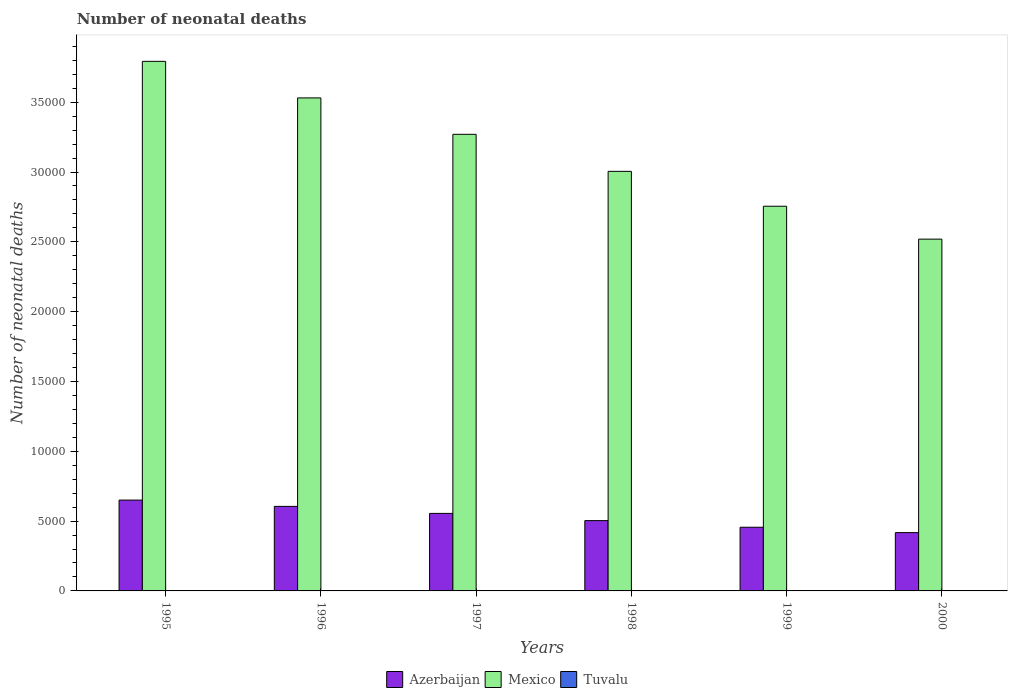Are the number of bars on each tick of the X-axis equal?
Make the answer very short. Yes. In how many cases, is the number of bars for a given year not equal to the number of legend labels?
Provide a short and direct response. 0. What is the number of neonatal deaths in in Mexico in 1997?
Ensure brevity in your answer.  3.27e+04. Across all years, what is the maximum number of neonatal deaths in in Mexico?
Your answer should be compact. 3.79e+04. In which year was the number of neonatal deaths in in Mexico maximum?
Provide a succinct answer. 1995. What is the total number of neonatal deaths in in Mexico in the graph?
Provide a succinct answer. 1.89e+05. What is the difference between the number of neonatal deaths in in Azerbaijan in 1995 and that in 1996?
Your response must be concise. 451. What is the difference between the number of neonatal deaths in in Tuvalu in 1997 and the number of neonatal deaths in in Mexico in 1998?
Make the answer very short. -3.00e+04. What is the average number of neonatal deaths in in Mexico per year?
Ensure brevity in your answer.  3.15e+04. In the year 2000, what is the difference between the number of neonatal deaths in in Tuvalu and number of neonatal deaths in in Azerbaijan?
Provide a short and direct response. -4169. In how many years, is the number of neonatal deaths in in Mexico greater than 2000?
Make the answer very short. 6. What is the ratio of the number of neonatal deaths in in Azerbaijan in 1995 to that in 2000?
Keep it short and to the point. 1.56. Is the number of neonatal deaths in in Azerbaijan in 1995 less than that in 1998?
Ensure brevity in your answer.  No. Is the difference between the number of neonatal deaths in in Tuvalu in 1995 and 1997 greater than the difference between the number of neonatal deaths in in Azerbaijan in 1995 and 1997?
Your response must be concise. No. What is the difference between the highest and the second highest number of neonatal deaths in in Tuvalu?
Make the answer very short. 0. What is the difference between the highest and the lowest number of neonatal deaths in in Mexico?
Make the answer very short. 1.27e+04. In how many years, is the number of neonatal deaths in in Mexico greater than the average number of neonatal deaths in in Mexico taken over all years?
Offer a terse response. 3. What does the 2nd bar from the left in 1999 represents?
Keep it short and to the point. Mexico. What does the 1st bar from the right in 1999 represents?
Your answer should be compact. Tuvalu. How many years are there in the graph?
Make the answer very short. 6. Are the values on the major ticks of Y-axis written in scientific E-notation?
Provide a succinct answer. No. Where does the legend appear in the graph?
Provide a short and direct response. Bottom center. How many legend labels are there?
Give a very brief answer. 3. How are the legend labels stacked?
Provide a succinct answer. Horizontal. What is the title of the graph?
Provide a short and direct response. Number of neonatal deaths. Does "Cabo Verde" appear as one of the legend labels in the graph?
Offer a terse response. No. What is the label or title of the X-axis?
Your answer should be compact. Years. What is the label or title of the Y-axis?
Offer a terse response. Number of neonatal deaths. What is the Number of neonatal deaths in Azerbaijan in 1995?
Your answer should be very brief. 6505. What is the Number of neonatal deaths of Mexico in 1995?
Your answer should be very brief. 3.79e+04. What is the Number of neonatal deaths of Tuvalu in 1995?
Your answer should be very brief. 6. What is the Number of neonatal deaths of Azerbaijan in 1996?
Offer a very short reply. 6054. What is the Number of neonatal deaths of Mexico in 1996?
Your response must be concise. 3.53e+04. What is the Number of neonatal deaths of Tuvalu in 1996?
Your answer should be compact. 6. What is the Number of neonatal deaths of Azerbaijan in 1997?
Ensure brevity in your answer.  5552. What is the Number of neonatal deaths in Mexico in 1997?
Your response must be concise. 3.27e+04. What is the Number of neonatal deaths of Tuvalu in 1997?
Make the answer very short. 7. What is the Number of neonatal deaths in Azerbaijan in 1998?
Offer a terse response. 5035. What is the Number of neonatal deaths of Mexico in 1998?
Your answer should be very brief. 3.00e+04. What is the Number of neonatal deaths of Azerbaijan in 1999?
Your response must be concise. 4560. What is the Number of neonatal deaths of Mexico in 1999?
Make the answer very short. 2.76e+04. What is the Number of neonatal deaths of Azerbaijan in 2000?
Ensure brevity in your answer.  4176. What is the Number of neonatal deaths of Mexico in 2000?
Keep it short and to the point. 2.52e+04. What is the Number of neonatal deaths of Tuvalu in 2000?
Give a very brief answer. 7. Across all years, what is the maximum Number of neonatal deaths in Azerbaijan?
Your answer should be compact. 6505. Across all years, what is the maximum Number of neonatal deaths of Mexico?
Keep it short and to the point. 3.79e+04. Across all years, what is the minimum Number of neonatal deaths of Azerbaijan?
Offer a terse response. 4176. Across all years, what is the minimum Number of neonatal deaths in Mexico?
Your response must be concise. 2.52e+04. What is the total Number of neonatal deaths in Azerbaijan in the graph?
Your answer should be compact. 3.19e+04. What is the total Number of neonatal deaths in Mexico in the graph?
Give a very brief answer. 1.89e+05. What is the total Number of neonatal deaths in Tuvalu in the graph?
Offer a very short reply. 40. What is the difference between the Number of neonatal deaths in Azerbaijan in 1995 and that in 1996?
Make the answer very short. 451. What is the difference between the Number of neonatal deaths in Mexico in 1995 and that in 1996?
Your answer should be compact. 2618. What is the difference between the Number of neonatal deaths of Tuvalu in 1995 and that in 1996?
Offer a terse response. 0. What is the difference between the Number of neonatal deaths of Azerbaijan in 1995 and that in 1997?
Provide a succinct answer. 953. What is the difference between the Number of neonatal deaths in Mexico in 1995 and that in 1997?
Provide a short and direct response. 5225. What is the difference between the Number of neonatal deaths in Tuvalu in 1995 and that in 1997?
Offer a terse response. -1. What is the difference between the Number of neonatal deaths in Azerbaijan in 1995 and that in 1998?
Your answer should be compact. 1470. What is the difference between the Number of neonatal deaths in Mexico in 1995 and that in 1998?
Offer a terse response. 7877. What is the difference between the Number of neonatal deaths of Azerbaijan in 1995 and that in 1999?
Offer a very short reply. 1945. What is the difference between the Number of neonatal deaths of Mexico in 1995 and that in 1999?
Provide a succinct answer. 1.04e+04. What is the difference between the Number of neonatal deaths in Azerbaijan in 1995 and that in 2000?
Offer a very short reply. 2329. What is the difference between the Number of neonatal deaths of Mexico in 1995 and that in 2000?
Your response must be concise. 1.27e+04. What is the difference between the Number of neonatal deaths of Azerbaijan in 1996 and that in 1997?
Provide a short and direct response. 502. What is the difference between the Number of neonatal deaths of Mexico in 1996 and that in 1997?
Your answer should be compact. 2607. What is the difference between the Number of neonatal deaths of Azerbaijan in 1996 and that in 1998?
Make the answer very short. 1019. What is the difference between the Number of neonatal deaths in Mexico in 1996 and that in 1998?
Give a very brief answer. 5259. What is the difference between the Number of neonatal deaths of Azerbaijan in 1996 and that in 1999?
Give a very brief answer. 1494. What is the difference between the Number of neonatal deaths of Mexico in 1996 and that in 1999?
Your response must be concise. 7757. What is the difference between the Number of neonatal deaths in Azerbaijan in 1996 and that in 2000?
Your response must be concise. 1878. What is the difference between the Number of neonatal deaths in Mexico in 1996 and that in 2000?
Keep it short and to the point. 1.01e+04. What is the difference between the Number of neonatal deaths of Tuvalu in 1996 and that in 2000?
Provide a short and direct response. -1. What is the difference between the Number of neonatal deaths of Azerbaijan in 1997 and that in 1998?
Offer a very short reply. 517. What is the difference between the Number of neonatal deaths of Mexico in 1997 and that in 1998?
Provide a short and direct response. 2652. What is the difference between the Number of neonatal deaths in Tuvalu in 1997 and that in 1998?
Your answer should be very brief. 0. What is the difference between the Number of neonatal deaths in Azerbaijan in 1997 and that in 1999?
Provide a short and direct response. 992. What is the difference between the Number of neonatal deaths in Mexico in 1997 and that in 1999?
Your answer should be compact. 5150. What is the difference between the Number of neonatal deaths in Tuvalu in 1997 and that in 1999?
Ensure brevity in your answer.  0. What is the difference between the Number of neonatal deaths of Azerbaijan in 1997 and that in 2000?
Your answer should be very brief. 1376. What is the difference between the Number of neonatal deaths in Mexico in 1997 and that in 2000?
Your response must be concise. 7507. What is the difference between the Number of neonatal deaths in Azerbaijan in 1998 and that in 1999?
Give a very brief answer. 475. What is the difference between the Number of neonatal deaths of Mexico in 1998 and that in 1999?
Offer a very short reply. 2498. What is the difference between the Number of neonatal deaths of Tuvalu in 1998 and that in 1999?
Ensure brevity in your answer.  0. What is the difference between the Number of neonatal deaths of Azerbaijan in 1998 and that in 2000?
Provide a succinct answer. 859. What is the difference between the Number of neonatal deaths in Mexico in 1998 and that in 2000?
Keep it short and to the point. 4855. What is the difference between the Number of neonatal deaths in Tuvalu in 1998 and that in 2000?
Ensure brevity in your answer.  0. What is the difference between the Number of neonatal deaths of Azerbaijan in 1999 and that in 2000?
Your response must be concise. 384. What is the difference between the Number of neonatal deaths of Mexico in 1999 and that in 2000?
Your response must be concise. 2357. What is the difference between the Number of neonatal deaths of Azerbaijan in 1995 and the Number of neonatal deaths of Mexico in 1996?
Your answer should be compact. -2.88e+04. What is the difference between the Number of neonatal deaths of Azerbaijan in 1995 and the Number of neonatal deaths of Tuvalu in 1996?
Your answer should be very brief. 6499. What is the difference between the Number of neonatal deaths of Mexico in 1995 and the Number of neonatal deaths of Tuvalu in 1996?
Your answer should be compact. 3.79e+04. What is the difference between the Number of neonatal deaths in Azerbaijan in 1995 and the Number of neonatal deaths in Mexico in 1997?
Give a very brief answer. -2.62e+04. What is the difference between the Number of neonatal deaths of Azerbaijan in 1995 and the Number of neonatal deaths of Tuvalu in 1997?
Make the answer very short. 6498. What is the difference between the Number of neonatal deaths of Mexico in 1995 and the Number of neonatal deaths of Tuvalu in 1997?
Your answer should be very brief. 3.79e+04. What is the difference between the Number of neonatal deaths of Azerbaijan in 1995 and the Number of neonatal deaths of Mexico in 1998?
Offer a very short reply. -2.35e+04. What is the difference between the Number of neonatal deaths in Azerbaijan in 1995 and the Number of neonatal deaths in Tuvalu in 1998?
Your answer should be very brief. 6498. What is the difference between the Number of neonatal deaths of Mexico in 1995 and the Number of neonatal deaths of Tuvalu in 1998?
Keep it short and to the point. 3.79e+04. What is the difference between the Number of neonatal deaths in Azerbaijan in 1995 and the Number of neonatal deaths in Mexico in 1999?
Provide a succinct answer. -2.10e+04. What is the difference between the Number of neonatal deaths of Azerbaijan in 1995 and the Number of neonatal deaths of Tuvalu in 1999?
Make the answer very short. 6498. What is the difference between the Number of neonatal deaths in Mexico in 1995 and the Number of neonatal deaths in Tuvalu in 1999?
Offer a very short reply. 3.79e+04. What is the difference between the Number of neonatal deaths in Azerbaijan in 1995 and the Number of neonatal deaths in Mexico in 2000?
Offer a terse response. -1.87e+04. What is the difference between the Number of neonatal deaths of Azerbaijan in 1995 and the Number of neonatal deaths of Tuvalu in 2000?
Provide a succinct answer. 6498. What is the difference between the Number of neonatal deaths of Mexico in 1995 and the Number of neonatal deaths of Tuvalu in 2000?
Your answer should be very brief. 3.79e+04. What is the difference between the Number of neonatal deaths of Azerbaijan in 1996 and the Number of neonatal deaths of Mexico in 1997?
Offer a terse response. -2.66e+04. What is the difference between the Number of neonatal deaths in Azerbaijan in 1996 and the Number of neonatal deaths in Tuvalu in 1997?
Provide a short and direct response. 6047. What is the difference between the Number of neonatal deaths of Mexico in 1996 and the Number of neonatal deaths of Tuvalu in 1997?
Provide a succinct answer. 3.53e+04. What is the difference between the Number of neonatal deaths in Azerbaijan in 1996 and the Number of neonatal deaths in Mexico in 1998?
Your answer should be compact. -2.40e+04. What is the difference between the Number of neonatal deaths in Azerbaijan in 1996 and the Number of neonatal deaths in Tuvalu in 1998?
Give a very brief answer. 6047. What is the difference between the Number of neonatal deaths in Mexico in 1996 and the Number of neonatal deaths in Tuvalu in 1998?
Give a very brief answer. 3.53e+04. What is the difference between the Number of neonatal deaths of Azerbaijan in 1996 and the Number of neonatal deaths of Mexico in 1999?
Ensure brevity in your answer.  -2.15e+04. What is the difference between the Number of neonatal deaths of Azerbaijan in 1996 and the Number of neonatal deaths of Tuvalu in 1999?
Keep it short and to the point. 6047. What is the difference between the Number of neonatal deaths of Mexico in 1996 and the Number of neonatal deaths of Tuvalu in 1999?
Your answer should be very brief. 3.53e+04. What is the difference between the Number of neonatal deaths in Azerbaijan in 1996 and the Number of neonatal deaths in Mexico in 2000?
Provide a succinct answer. -1.91e+04. What is the difference between the Number of neonatal deaths of Azerbaijan in 1996 and the Number of neonatal deaths of Tuvalu in 2000?
Your response must be concise. 6047. What is the difference between the Number of neonatal deaths in Mexico in 1996 and the Number of neonatal deaths in Tuvalu in 2000?
Offer a very short reply. 3.53e+04. What is the difference between the Number of neonatal deaths of Azerbaijan in 1997 and the Number of neonatal deaths of Mexico in 1998?
Your answer should be very brief. -2.45e+04. What is the difference between the Number of neonatal deaths of Azerbaijan in 1997 and the Number of neonatal deaths of Tuvalu in 1998?
Your answer should be very brief. 5545. What is the difference between the Number of neonatal deaths of Mexico in 1997 and the Number of neonatal deaths of Tuvalu in 1998?
Make the answer very short. 3.27e+04. What is the difference between the Number of neonatal deaths of Azerbaijan in 1997 and the Number of neonatal deaths of Mexico in 1999?
Provide a succinct answer. -2.20e+04. What is the difference between the Number of neonatal deaths of Azerbaijan in 1997 and the Number of neonatal deaths of Tuvalu in 1999?
Give a very brief answer. 5545. What is the difference between the Number of neonatal deaths in Mexico in 1997 and the Number of neonatal deaths in Tuvalu in 1999?
Your response must be concise. 3.27e+04. What is the difference between the Number of neonatal deaths in Azerbaijan in 1997 and the Number of neonatal deaths in Mexico in 2000?
Your answer should be compact. -1.96e+04. What is the difference between the Number of neonatal deaths of Azerbaijan in 1997 and the Number of neonatal deaths of Tuvalu in 2000?
Your answer should be very brief. 5545. What is the difference between the Number of neonatal deaths in Mexico in 1997 and the Number of neonatal deaths in Tuvalu in 2000?
Offer a terse response. 3.27e+04. What is the difference between the Number of neonatal deaths in Azerbaijan in 1998 and the Number of neonatal deaths in Mexico in 1999?
Offer a very short reply. -2.25e+04. What is the difference between the Number of neonatal deaths in Azerbaijan in 1998 and the Number of neonatal deaths in Tuvalu in 1999?
Your answer should be compact. 5028. What is the difference between the Number of neonatal deaths in Mexico in 1998 and the Number of neonatal deaths in Tuvalu in 1999?
Your answer should be compact. 3.00e+04. What is the difference between the Number of neonatal deaths of Azerbaijan in 1998 and the Number of neonatal deaths of Mexico in 2000?
Ensure brevity in your answer.  -2.02e+04. What is the difference between the Number of neonatal deaths in Azerbaijan in 1998 and the Number of neonatal deaths in Tuvalu in 2000?
Give a very brief answer. 5028. What is the difference between the Number of neonatal deaths in Mexico in 1998 and the Number of neonatal deaths in Tuvalu in 2000?
Your answer should be compact. 3.00e+04. What is the difference between the Number of neonatal deaths of Azerbaijan in 1999 and the Number of neonatal deaths of Mexico in 2000?
Your answer should be very brief. -2.06e+04. What is the difference between the Number of neonatal deaths in Azerbaijan in 1999 and the Number of neonatal deaths in Tuvalu in 2000?
Offer a terse response. 4553. What is the difference between the Number of neonatal deaths of Mexico in 1999 and the Number of neonatal deaths of Tuvalu in 2000?
Your answer should be compact. 2.75e+04. What is the average Number of neonatal deaths of Azerbaijan per year?
Make the answer very short. 5313.67. What is the average Number of neonatal deaths of Mexico per year?
Keep it short and to the point. 3.15e+04. What is the average Number of neonatal deaths of Tuvalu per year?
Your answer should be compact. 6.67. In the year 1995, what is the difference between the Number of neonatal deaths of Azerbaijan and Number of neonatal deaths of Mexico?
Your answer should be very brief. -3.14e+04. In the year 1995, what is the difference between the Number of neonatal deaths in Azerbaijan and Number of neonatal deaths in Tuvalu?
Ensure brevity in your answer.  6499. In the year 1995, what is the difference between the Number of neonatal deaths of Mexico and Number of neonatal deaths of Tuvalu?
Your answer should be very brief. 3.79e+04. In the year 1996, what is the difference between the Number of neonatal deaths in Azerbaijan and Number of neonatal deaths in Mexico?
Provide a succinct answer. -2.93e+04. In the year 1996, what is the difference between the Number of neonatal deaths in Azerbaijan and Number of neonatal deaths in Tuvalu?
Give a very brief answer. 6048. In the year 1996, what is the difference between the Number of neonatal deaths of Mexico and Number of neonatal deaths of Tuvalu?
Offer a very short reply. 3.53e+04. In the year 1997, what is the difference between the Number of neonatal deaths of Azerbaijan and Number of neonatal deaths of Mexico?
Provide a succinct answer. -2.71e+04. In the year 1997, what is the difference between the Number of neonatal deaths of Azerbaijan and Number of neonatal deaths of Tuvalu?
Your answer should be compact. 5545. In the year 1997, what is the difference between the Number of neonatal deaths in Mexico and Number of neonatal deaths in Tuvalu?
Your response must be concise. 3.27e+04. In the year 1998, what is the difference between the Number of neonatal deaths of Azerbaijan and Number of neonatal deaths of Mexico?
Your answer should be compact. -2.50e+04. In the year 1998, what is the difference between the Number of neonatal deaths of Azerbaijan and Number of neonatal deaths of Tuvalu?
Provide a short and direct response. 5028. In the year 1998, what is the difference between the Number of neonatal deaths of Mexico and Number of neonatal deaths of Tuvalu?
Provide a succinct answer. 3.00e+04. In the year 1999, what is the difference between the Number of neonatal deaths of Azerbaijan and Number of neonatal deaths of Mexico?
Your response must be concise. -2.30e+04. In the year 1999, what is the difference between the Number of neonatal deaths in Azerbaijan and Number of neonatal deaths in Tuvalu?
Offer a terse response. 4553. In the year 1999, what is the difference between the Number of neonatal deaths in Mexico and Number of neonatal deaths in Tuvalu?
Make the answer very short. 2.75e+04. In the year 2000, what is the difference between the Number of neonatal deaths of Azerbaijan and Number of neonatal deaths of Mexico?
Your answer should be very brief. -2.10e+04. In the year 2000, what is the difference between the Number of neonatal deaths of Azerbaijan and Number of neonatal deaths of Tuvalu?
Give a very brief answer. 4169. In the year 2000, what is the difference between the Number of neonatal deaths of Mexico and Number of neonatal deaths of Tuvalu?
Offer a very short reply. 2.52e+04. What is the ratio of the Number of neonatal deaths of Azerbaijan in 1995 to that in 1996?
Your answer should be very brief. 1.07. What is the ratio of the Number of neonatal deaths in Mexico in 1995 to that in 1996?
Ensure brevity in your answer.  1.07. What is the ratio of the Number of neonatal deaths in Tuvalu in 1995 to that in 1996?
Make the answer very short. 1. What is the ratio of the Number of neonatal deaths in Azerbaijan in 1995 to that in 1997?
Make the answer very short. 1.17. What is the ratio of the Number of neonatal deaths in Mexico in 1995 to that in 1997?
Provide a succinct answer. 1.16. What is the ratio of the Number of neonatal deaths in Azerbaijan in 1995 to that in 1998?
Your response must be concise. 1.29. What is the ratio of the Number of neonatal deaths in Mexico in 1995 to that in 1998?
Provide a short and direct response. 1.26. What is the ratio of the Number of neonatal deaths of Azerbaijan in 1995 to that in 1999?
Make the answer very short. 1.43. What is the ratio of the Number of neonatal deaths of Mexico in 1995 to that in 1999?
Offer a terse response. 1.38. What is the ratio of the Number of neonatal deaths of Tuvalu in 1995 to that in 1999?
Make the answer very short. 0.86. What is the ratio of the Number of neonatal deaths of Azerbaijan in 1995 to that in 2000?
Your answer should be compact. 1.56. What is the ratio of the Number of neonatal deaths of Mexico in 1995 to that in 2000?
Your answer should be compact. 1.51. What is the ratio of the Number of neonatal deaths in Azerbaijan in 1996 to that in 1997?
Make the answer very short. 1.09. What is the ratio of the Number of neonatal deaths in Mexico in 1996 to that in 1997?
Keep it short and to the point. 1.08. What is the ratio of the Number of neonatal deaths of Tuvalu in 1996 to that in 1997?
Your answer should be very brief. 0.86. What is the ratio of the Number of neonatal deaths in Azerbaijan in 1996 to that in 1998?
Offer a terse response. 1.2. What is the ratio of the Number of neonatal deaths in Mexico in 1996 to that in 1998?
Offer a terse response. 1.18. What is the ratio of the Number of neonatal deaths in Azerbaijan in 1996 to that in 1999?
Provide a short and direct response. 1.33. What is the ratio of the Number of neonatal deaths in Mexico in 1996 to that in 1999?
Make the answer very short. 1.28. What is the ratio of the Number of neonatal deaths in Tuvalu in 1996 to that in 1999?
Provide a succinct answer. 0.86. What is the ratio of the Number of neonatal deaths in Azerbaijan in 1996 to that in 2000?
Make the answer very short. 1.45. What is the ratio of the Number of neonatal deaths in Mexico in 1996 to that in 2000?
Keep it short and to the point. 1.4. What is the ratio of the Number of neonatal deaths in Azerbaijan in 1997 to that in 1998?
Provide a short and direct response. 1.1. What is the ratio of the Number of neonatal deaths of Mexico in 1997 to that in 1998?
Ensure brevity in your answer.  1.09. What is the ratio of the Number of neonatal deaths of Azerbaijan in 1997 to that in 1999?
Your response must be concise. 1.22. What is the ratio of the Number of neonatal deaths in Mexico in 1997 to that in 1999?
Offer a very short reply. 1.19. What is the ratio of the Number of neonatal deaths in Tuvalu in 1997 to that in 1999?
Provide a succinct answer. 1. What is the ratio of the Number of neonatal deaths of Azerbaijan in 1997 to that in 2000?
Make the answer very short. 1.33. What is the ratio of the Number of neonatal deaths in Mexico in 1997 to that in 2000?
Your answer should be very brief. 1.3. What is the ratio of the Number of neonatal deaths of Tuvalu in 1997 to that in 2000?
Your response must be concise. 1. What is the ratio of the Number of neonatal deaths of Azerbaijan in 1998 to that in 1999?
Make the answer very short. 1.1. What is the ratio of the Number of neonatal deaths of Mexico in 1998 to that in 1999?
Your response must be concise. 1.09. What is the ratio of the Number of neonatal deaths of Azerbaijan in 1998 to that in 2000?
Keep it short and to the point. 1.21. What is the ratio of the Number of neonatal deaths in Mexico in 1998 to that in 2000?
Provide a succinct answer. 1.19. What is the ratio of the Number of neonatal deaths of Azerbaijan in 1999 to that in 2000?
Your answer should be compact. 1.09. What is the ratio of the Number of neonatal deaths of Mexico in 1999 to that in 2000?
Provide a short and direct response. 1.09. What is the ratio of the Number of neonatal deaths of Tuvalu in 1999 to that in 2000?
Your answer should be compact. 1. What is the difference between the highest and the second highest Number of neonatal deaths of Azerbaijan?
Your response must be concise. 451. What is the difference between the highest and the second highest Number of neonatal deaths of Mexico?
Provide a short and direct response. 2618. What is the difference between the highest and the lowest Number of neonatal deaths in Azerbaijan?
Your answer should be compact. 2329. What is the difference between the highest and the lowest Number of neonatal deaths of Mexico?
Make the answer very short. 1.27e+04. What is the difference between the highest and the lowest Number of neonatal deaths in Tuvalu?
Offer a very short reply. 1. 